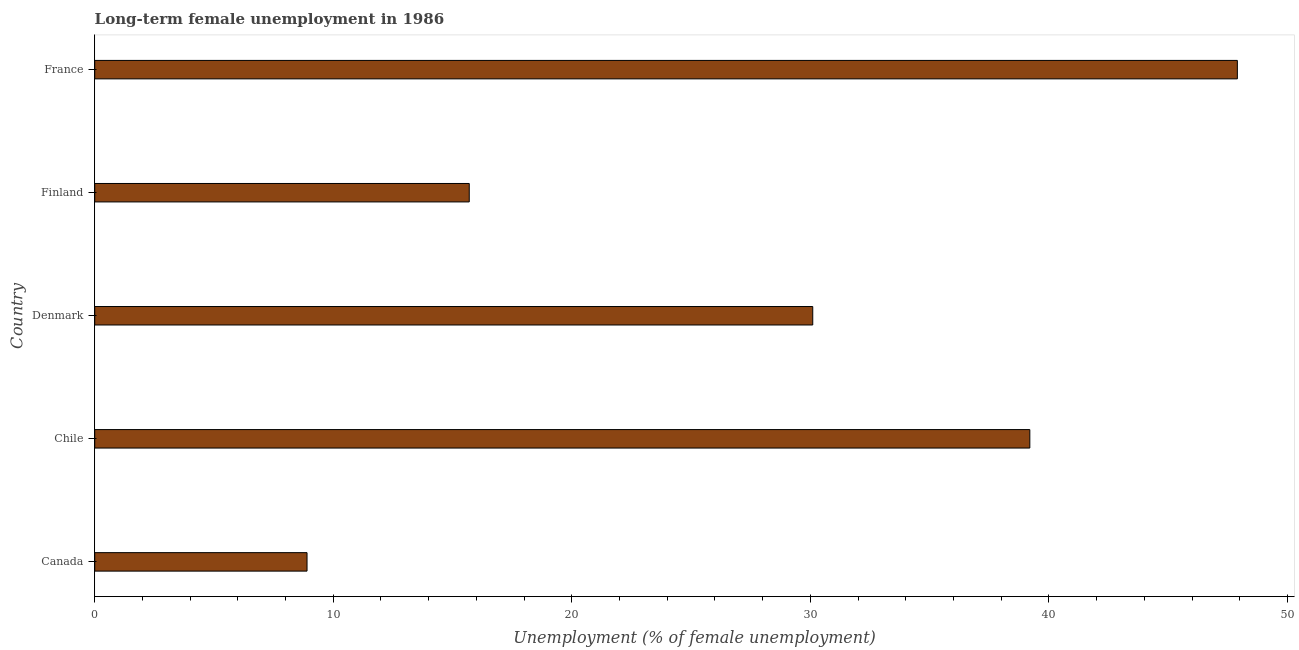What is the title of the graph?
Offer a terse response. Long-term female unemployment in 1986. What is the label or title of the X-axis?
Provide a short and direct response. Unemployment (% of female unemployment). What is the label or title of the Y-axis?
Offer a very short reply. Country. What is the long-term female unemployment in France?
Provide a short and direct response. 47.9. Across all countries, what is the maximum long-term female unemployment?
Offer a very short reply. 47.9. Across all countries, what is the minimum long-term female unemployment?
Offer a very short reply. 8.9. What is the sum of the long-term female unemployment?
Offer a very short reply. 141.8. What is the average long-term female unemployment per country?
Your answer should be compact. 28.36. What is the median long-term female unemployment?
Your response must be concise. 30.1. What is the ratio of the long-term female unemployment in Chile to that in Finland?
Your answer should be compact. 2.5. Is the long-term female unemployment in Canada less than that in Finland?
Keep it short and to the point. Yes. What is the difference between the highest and the second highest long-term female unemployment?
Make the answer very short. 8.7. Is the sum of the long-term female unemployment in Chile and Finland greater than the maximum long-term female unemployment across all countries?
Your response must be concise. Yes. In how many countries, is the long-term female unemployment greater than the average long-term female unemployment taken over all countries?
Your answer should be compact. 3. How many bars are there?
Your answer should be very brief. 5. Are all the bars in the graph horizontal?
Provide a short and direct response. Yes. What is the difference between two consecutive major ticks on the X-axis?
Offer a terse response. 10. What is the Unemployment (% of female unemployment) of Canada?
Your answer should be very brief. 8.9. What is the Unemployment (% of female unemployment) in Chile?
Ensure brevity in your answer.  39.2. What is the Unemployment (% of female unemployment) of Denmark?
Your answer should be very brief. 30.1. What is the Unemployment (% of female unemployment) in Finland?
Keep it short and to the point. 15.7. What is the Unemployment (% of female unemployment) in France?
Provide a short and direct response. 47.9. What is the difference between the Unemployment (% of female unemployment) in Canada and Chile?
Keep it short and to the point. -30.3. What is the difference between the Unemployment (% of female unemployment) in Canada and Denmark?
Offer a very short reply. -21.2. What is the difference between the Unemployment (% of female unemployment) in Canada and Finland?
Your response must be concise. -6.8. What is the difference between the Unemployment (% of female unemployment) in Canada and France?
Provide a short and direct response. -39. What is the difference between the Unemployment (% of female unemployment) in Chile and Denmark?
Provide a succinct answer. 9.1. What is the difference between the Unemployment (% of female unemployment) in Chile and Finland?
Offer a very short reply. 23.5. What is the difference between the Unemployment (% of female unemployment) in Denmark and Finland?
Your answer should be compact. 14.4. What is the difference between the Unemployment (% of female unemployment) in Denmark and France?
Offer a terse response. -17.8. What is the difference between the Unemployment (% of female unemployment) in Finland and France?
Your answer should be very brief. -32.2. What is the ratio of the Unemployment (% of female unemployment) in Canada to that in Chile?
Your answer should be compact. 0.23. What is the ratio of the Unemployment (% of female unemployment) in Canada to that in Denmark?
Your answer should be compact. 0.3. What is the ratio of the Unemployment (% of female unemployment) in Canada to that in Finland?
Your answer should be very brief. 0.57. What is the ratio of the Unemployment (% of female unemployment) in Canada to that in France?
Your response must be concise. 0.19. What is the ratio of the Unemployment (% of female unemployment) in Chile to that in Denmark?
Ensure brevity in your answer.  1.3. What is the ratio of the Unemployment (% of female unemployment) in Chile to that in Finland?
Give a very brief answer. 2.5. What is the ratio of the Unemployment (% of female unemployment) in Chile to that in France?
Give a very brief answer. 0.82. What is the ratio of the Unemployment (% of female unemployment) in Denmark to that in Finland?
Offer a very short reply. 1.92. What is the ratio of the Unemployment (% of female unemployment) in Denmark to that in France?
Your response must be concise. 0.63. What is the ratio of the Unemployment (% of female unemployment) in Finland to that in France?
Your answer should be very brief. 0.33. 